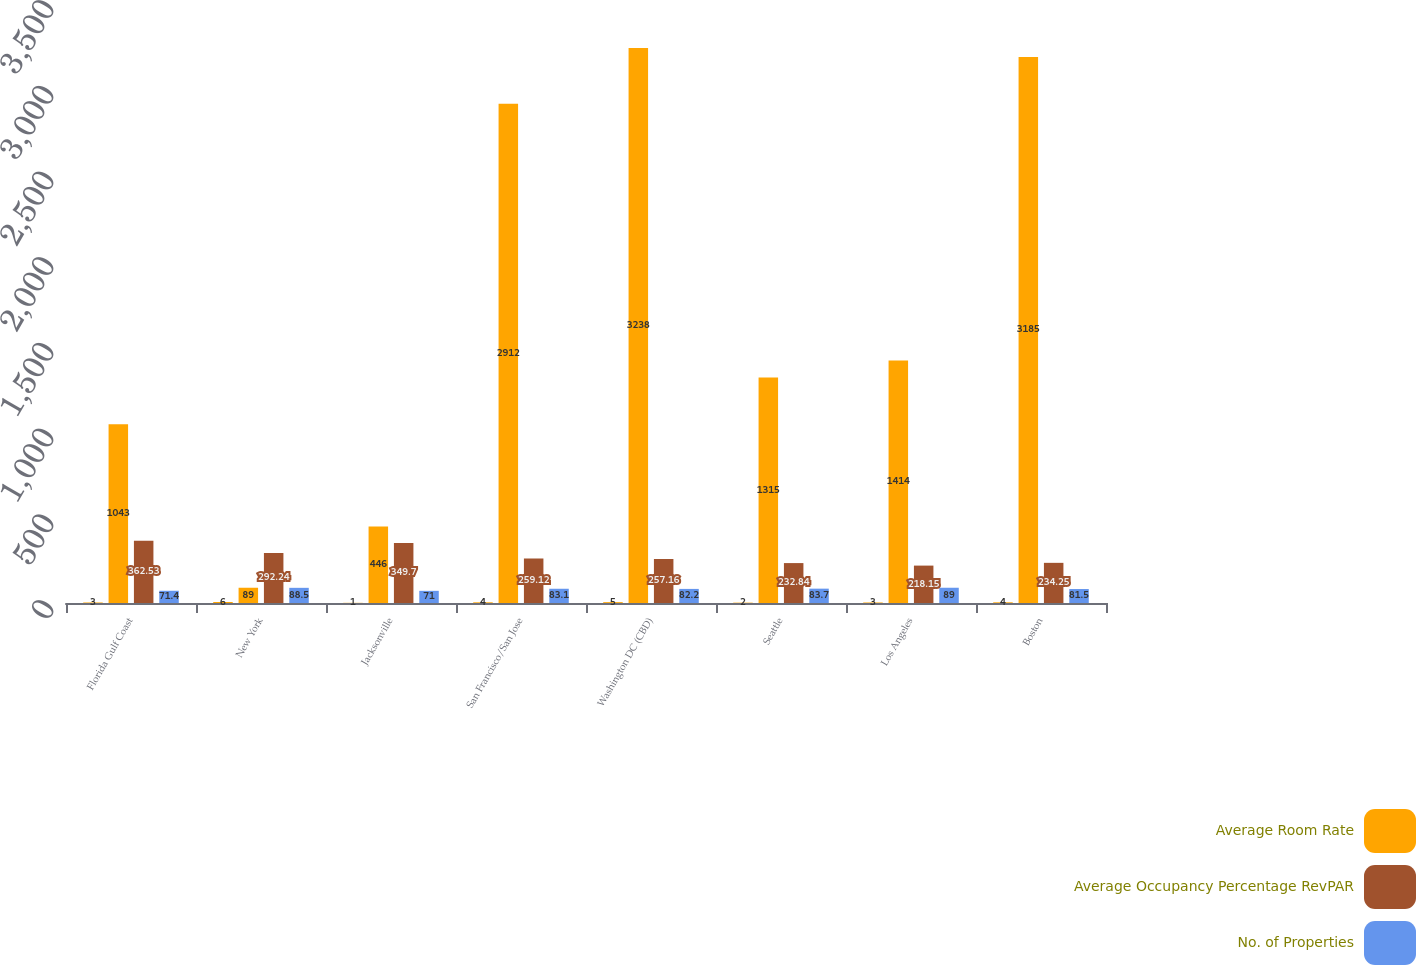Convert chart. <chart><loc_0><loc_0><loc_500><loc_500><stacked_bar_chart><ecel><fcel>Florida Gulf Coast<fcel>New York<fcel>Jacksonville<fcel>San Francisco/San Jose<fcel>Washington DC (CBD)<fcel>Seattle<fcel>Los Angeles<fcel>Boston<nl><fcel>nan<fcel>3<fcel>6<fcel>1<fcel>4<fcel>5<fcel>2<fcel>3<fcel>4<nl><fcel>Average Room Rate<fcel>1043<fcel>89<fcel>446<fcel>2912<fcel>3238<fcel>1315<fcel>1414<fcel>3185<nl><fcel>Average Occupancy Percentage RevPAR<fcel>362.53<fcel>292.24<fcel>349.7<fcel>259.12<fcel>257.16<fcel>232.84<fcel>218.15<fcel>234.25<nl><fcel>No. of Properties<fcel>71.4<fcel>88.5<fcel>71<fcel>83.1<fcel>82.2<fcel>83.7<fcel>89<fcel>81.5<nl></chart> 